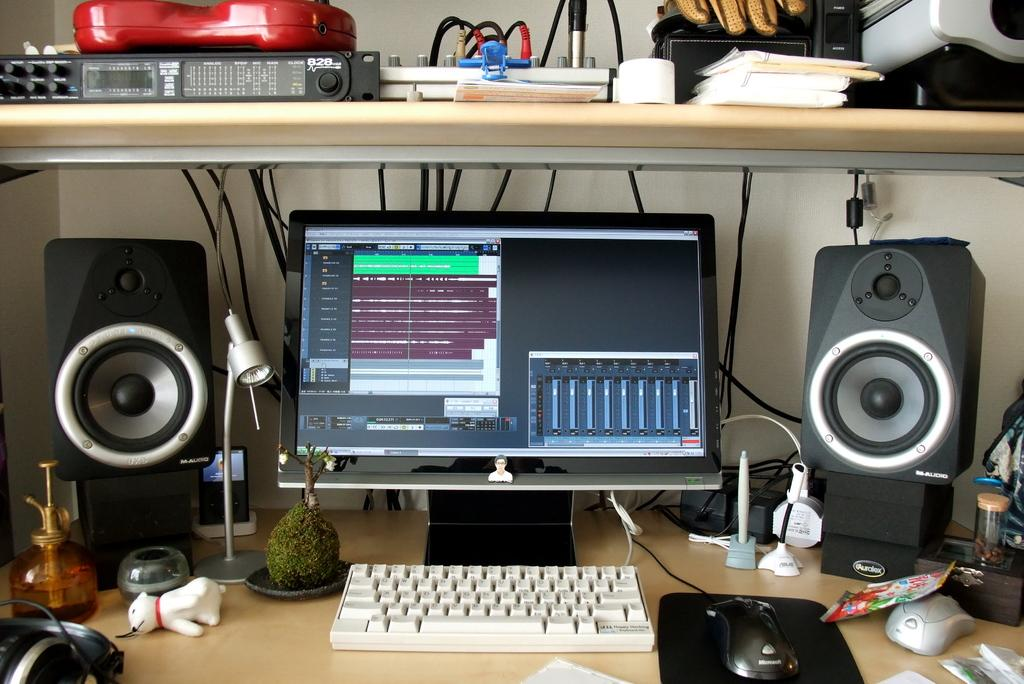What type of electronic device is in the image? There is a computer in the image. What are some accessories that can be seen with the computer? There are speakers, a keyboard, a mouse, a mouse pad, and headphones in the image. What other objects are present on the table? There is a lamp, a plant, books, and a toy on the table. How are the wires arranged in the image? The wires are visible in the image, connecting some of the devices. What type of smoke can be seen coming from the computer in the image? There is no smoke coming from the computer in the image. What key is used to unlock the toy in the image? There is no key mentioned or implied in the image, and the toy does not require a key to unlock. 